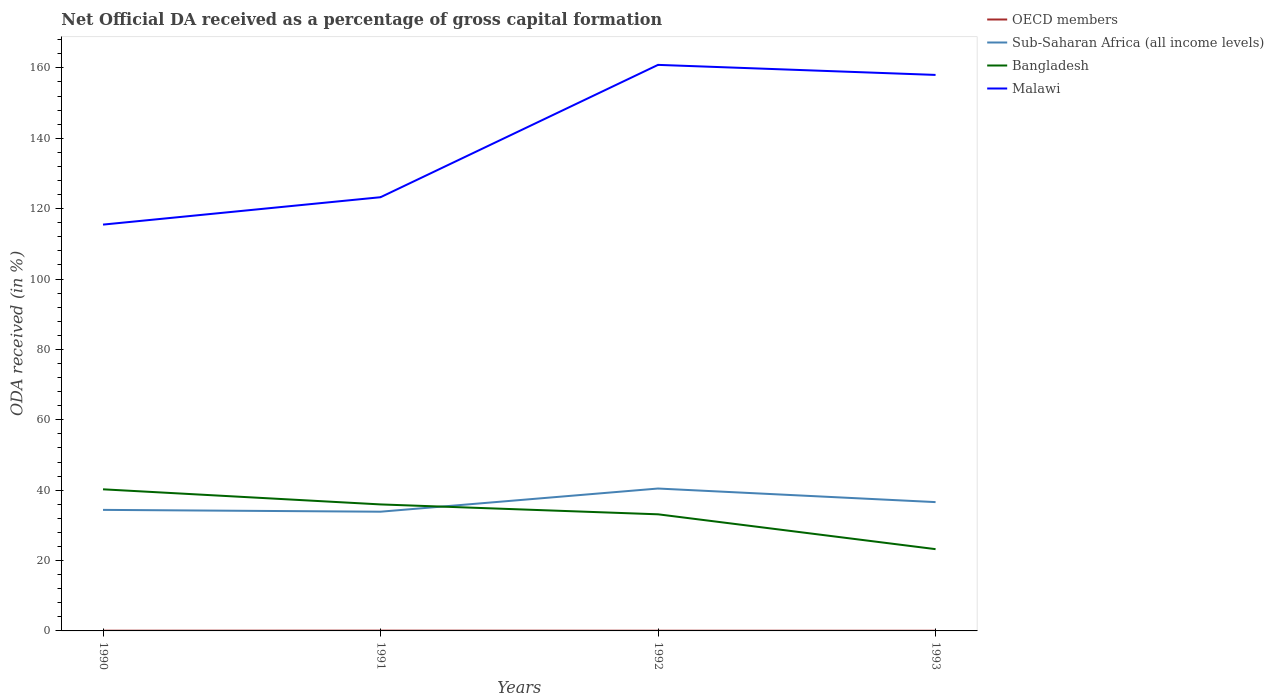Does the line corresponding to Malawi intersect with the line corresponding to Bangladesh?
Offer a terse response. No. Is the number of lines equal to the number of legend labels?
Keep it short and to the point. Yes. Across all years, what is the maximum net ODA received in Sub-Saharan Africa (all income levels)?
Make the answer very short. 33.88. In which year was the net ODA received in Bangladesh maximum?
Your response must be concise. 1993. What is the total net ODA received in OECD members in the graph?
Provide a succinct answer. 0.03. What is the difference between the highest and the second highest net ODA received in Malawi?
Keep it short and to the point. 45.39. What is the difference between the highest and the lowest net ODA received in Malawi?
Your answer should be compact. 2. Is the net ODA received in Malawi strictly greater than the net ODA received in Bangladesh over the years?
Your answer should be compact. No. How many lines are there?
Ensure brevity in your answer.  4. How many years are there in the graph?
Your answer should be very brief. 4. What is the difference between two consecutive major ticks on the Y-axis?
Provide a short and direct response. 20. Are the values on the major ticks of Y-axis written in scientific E-notation?
Keep it short and to the point. No. How many legend labels are there?
Provide a short and direct response. 4. What is the title of the graph?
Provide a succinct answer. Net Official DA received as a percentage of gross capital formation. What is the label or title of the Y-axis?
Offer a very short reply. ODA received (in %). What is the ODA received (in %) in OECD members in 1990?
Your answer should be compact. 0.06. What is the ODA received (in %) in Sub-Saharan Africa (all income levels) in 1990?
Give a very brief answer. 34.4. What is the ODA received (in %) in Bangladesh in 1990?
Your response must be concise. 40.24. What is the ODA received (in %) of Malawi in 1990?
Give a very brief answer. 115.47. What is the ODA received (in %) in OECD members in 1991?
Offer a terse response. 0.08. What is the ODA received (in %) in Sub-Saharan Africa (all income levels) in 1991?
Ensure brevity in your answer.  33.88. What is the ODA received (in %) in Bangladesh in 1991?
Offer a terse response. 35.95. What is the ODA received (in %) of Malawi in 1991?
Keep it short and to the point. 123.25. What is the ODA received (in %) in OECD members in 1992?
Your answer should be compact. 0.06. What is the ODA received (in %) of Sub-Saharan Africa (all income levels) in 1992?
Your answer should be compact. 40.46. What is the ODA received (in %) of Bangladesh in 1992?
Provide a succinct answer. 33.14. What is the ODA received (in %) of Malawi in 1992?
Your answer should be compact. 160.86. What is the ODA received (in %) in OECD members in 1993?
Your answer should be very brief. 0.05. What is the ODA received (in %) of Sub-Saharan Africa (all income levels) in 1993?
Provide a succinct answer. 36.6. What is the ODA received (in %) in Bangladesh in 1993?
Offer a terse response. 23.24. What is the ODA received (in %) in Malawi in 1993?
Offer a terse response. 158. Across all years, what is the maximum ODA received (in %) in OECD members?
Keep it short and to the point. 0.08. Across all years, what is the maximum ODA received (in %) of Sub-Saharan Africa (all income levels)?
Give a very brief answer. 40.46. Across all years, what is the maximum ODA received (in %) in Bangladesh?
Keep it short and to the point. 40.24. Across all years, what is the maximum ODA received (in %) in Malawi?
Provide a short and direct response. 160.86. Across all years, what is the minimum ODA received (in %) in OECD members?
Your answer should be compact. 0.05. Across all years, what is the minimum ODA received (in %) in Sub-Saharan Africa (all income levels)?
Provide a succinct answer. 33.88. Across all years, what is the minimum ODA received (in %) of Bangladesh?
Offer a terse response. 23.24. Across all years, what is the minimum ODA received (in %) in Malawi?
Offer a terse response. 115.47. What is the total ODA received (in %) of OECD members in the graph?
Provide a short and direct response. 0.25. What is the total ODA received (in %) in Sub-Saharan Africa (all income levels) in the graph?
Your answer should be very brief. 145.35. What is the total ODA received (in %) of Bangladesh in the graph?
Keep it short and to the point. 132.56. What is the total ODA received (in %) of Malawi in the graph?
Your answer should be compact. 557.57. What is the difference between the ODA received (in %) in OECD members in 1990 and that in 1991?
Provide a short and direct response. -0.02. What is the difference between the ODA received (in %) in Sub-Saharan Africa (all income levels) in 1990 and that in 1991?
Your answer should be compact. 0.52. What is the difference between the ODA received (in %) of Bangladesh in 1990 and that in 1991?
Offer a very short reply. 4.29. What is the difference between the ODA received (in %) in Malawi in 1990 and that in 1991?
Make the answer very short. -7.78. What is the difference between the ODA received (in %) in OECD members in 1990 and that in 1992?
Provide a short and direct response. 0.01. What is the difference between the ODA received (in %) of Sub-Saharan Africa (all income levels) in 1990 and that in 1992?
Your response must be concise. -6.07. What is the difference between the ODA received (in %) of Bangladesh in 1990 and that in 1992?
Offer a very short reply. 7.1. What is the difference between the ODA received (in %) in Malawi in 1990 and that in 1992?
Give a very brief answer. -45.39. What is the difference between the ODA received (in %) of OECD members in 1990 and that in 1993?
Give a very brief answer. 0.02. What is the difference between the ODA received (in %) of Sub-Saharan Africa (all income levels) in 1990 and that in 1993?
Keep it short and to the point. -2.2. What is the difference between the ODA received (in %) of Bangladesh in 1990 and that in 1993?
Offer a terse response. 17. What is the difference between the ODA received (in %) of Malawi in 1990 and that in 1993?
Provide a short and direct response. -42.53. What is the difference between the ODA received (in %) of OECD members in 1991 and that in 1992?
Make the answer very short. 0.02. What is the difference between the ODA received (in %) of Sub-Saharan Africa (all income levels) in 1991 and that in 1992?
Your response must be concise. -6.58. What is the difference between the ODA received (in %) of Bangladesh in 1991 and that in 1992?
Offer a very short reply. 2.81. What is the difference between the ODA received (in %) in Malawi in 1991 and that in 1992?
Your response must be concise. -37.61. What is the difference between the ODA received (in %) of OECD members in 1991 and that in 1993?
Ensure brevity in your answer.  0.03. What is the difference between the ODA received (in %) of Sub-Saharan Africa (all income levels) in 1991 and that in 1993?
Offer a terse response. -2.72. What is the difference between the ODA received (in %) of Bangladesh in 1991 and that in 1993?
Make the answer very short. 12.71. What is the difference between the ODA received (in %) in Malawi in 1991 and that in 1993?
Your answer should be compact. -34.75. What is the difference between the ODA received (in %) of OECD members in 1992 and that in 1993?
Make the answer very short. 0.01. What is the difference between the ODA received (in %) in Sub-Saharan Africa (all income levels) in 1992 and that in 1993?
Provide a succinct answer. 3.86. What is the difference between the ODA received (in %) of Bangladesh in 1992 and that in 1993?
Provide a succinct answer. 9.9. What is the difference between the ODA received (in %) of Malawi in 1992 and that in 1993?
Your answer should be compact. 2.86. What is the difference between the ODA received (in %) of OECD members in 1990 and the ODA received (in %) of Sub-Saharan Africa (all income levels) in 1991?
Offer a terse response. -33.82. What is the difference between the ODA received (in %) of OECD members in 1990 and the ODA received (in %) of Bangladesh in 1991?
Give a very brief answer. -35.88. What is the difference between the ODA received (in %) in OECD members in 1990 and the ODA received (in %) in Malawi in 1991?
Provide a succinct answer. -123.19. What is the difference between the ODA received (in %) of Sub-Saharan Africa (all income levels) in 1990 and the ODA received (in %) of Bangladesh in 1991?
Provide a short and direct response. -1.55. What is the difference between the ODA received (in %) in Sub-Saharan Africa (all income levels) in 1990 and the ODA received (in %) in Malawi in 1991?
Keep it short and to the point. -88.85. What is the difference between the ODA received (in %) in Bangladesh in 1990 and the ODA received (in %) in Malawi in 1991?
Your response must be concise. -83.01. What is the difference between the ODA received (in %) of OECD members in 1990 and the ODA received (in %) of Sub-Saharan Africa (all income levels) in 1992?
Your answer should be very brief. -40.4. What is the difference between the ODA received (in %) in OECD members in 1990 and the ODA received (in %) in Bangladesh in 1992?
Offer a very short reply. -33.07. What is the difference between the ODA received (in %) in OECD members in 1990 and the ODA received (in %) in Malawi in 1992?
Provide a succinct answer. -160.79. What is the difference between the ODA received (in %) of Sub-Saharan Africa (all income levels) in 1990 and the ODA received (in %) of Bangladesh in 1992?
Provide a short and direct response. 1.26. What is the difference between the ODA received (in %) in Sub-Saharan Africa (all income levels) in 1990 and the ODA received (in %) in Malawi in 1992?
Provide a short and direct response. -126.46. What is the difference between the ODA received (in %) in Bangladesh in 1990 and the ODA received (in %) in Malawi in 1992?
Keep it short and to the point. -120.62. What is the difference between the ODA received (in %) in OECD members in 1990 and the ODA received (in %) in Sub-Saharan Africa (all income levels) in 1993?
Make the answer very short. -36.54. What is the difference between the ODA received (in %) in OECD members in 1990 and the ODA received (in %) in Bangladesh in 1993?
Provide a succinct answer. -23.17. What is the difference between the ODA received (in %) in OECD members in 1990 and the ODA received (in %) in Malawi in 1993?
Provide a short and direct response. -157.93. What is the difference between the ODA received (in %) in Sub-Saharan Africa (all income levels) in 1990 and the ODA received (in %) in Bangladesh in 1993?
Offer a terse response. 11.16. What is the difference between the ODA received (in %) of Sub-Saharan Africa (all income levels) in 1990 and the ODA received (in %) of Malawi in 1993?
Your response must be concise. -123.6. What is the difference between the ODA received (in %) of Bangladesh in 1990 and the ODA received (in %) of Malawi in 1993?
Keep it short and to the point. -117.76. What is the difference between the ODA received (in %) of OECD members in 1991 and the ODA received (in %) of Sub-Saharan Africa (all income levels) in 1992?
Keep it short and to the point. -40.38. What is the difference between the ODA received (in %) in OECD members in 1991 and the ODA received (in %) in Bangladesh in 1992?
Provide a short and direct response. -33.06. What is the difference between the ODA received (in %) in OECD members in 1991 and the ODA received (in %) in Malawi in 1992?
Keep it short and to the point. -160.78. What is the difference between the ODA received (in %) in Sub-Saharan Africa (all income levels) in 1991 and the ODA received (in %) in Bangladesh in 1992?
Give a very brief answer. 0.74. What is the difference between the ODA received (in %) in Sub-Saharan Africa (all income levels) in 1991 and the ODA received (in %) in Malawi in 1992?
Ensure brevity in your answer.  -126.98. What is the difference between the ODA received (in %) of Bangladesh in 1991 and the ODA received (in %) of Malawi in 1992?
Your answer should be compact. -124.91. What is the difference between the ODA received (in %) in OECD members in 1991 and the ODA received (in %) in Sub-Saharan Africa (all income levels) in 1993?
Offer a very short reply. -36.52. What is the difference between the ODA received (in %) of OECD members in 1991 and the ODA received (in %) of Bangladesh in 1993?
Ensure brevity in your answer.  -23.16. What is the difference between the ODA received (in %) in OECD members in 1991 and the ODA received (in %) in Malawi in 1993?
Your answer should be very brief. -157.92. What is the difference between the ODA received (in %) in Sub-Saharan Africa (all income levels) in 1991 and the ODA received (in %) in Bangladesh in 1993?
Provide a short and direct response. 10.64. What is the difference between the ODA received (in %) in Sub-Saharan Africa (all income levels) in 1991 and the ODA received (in %) in Malawi in 1993?
Your answer should be very brief. -124.12. What is the difference between the ODA received (in %) in Bangladesh in 1991 and the ODA received (in %) in Malawi in 1993?
Provide a succinct answer. -122.05. What is the difference between the ODA received (in %) of OECD members in 1992 and the ODA received (in %) of Sub-Saharan Africa (all income levels) in 1993?
Offer a terse response. -36.55. What is the difference between the ODA received (in %) of OECD members in 1992 and the ODA received (in %) of Bangladesh in 1993?
Make the answer very short. -23.18. What is the difference between the ODA received (in %) in OECD members in 1992 and the ODA received (in %) in Malawi in 1993?
Keep it short and to the point. -157.94. What is the difference between the ODA received (in %) of Sub-Saharan Africa (all income levels) in 1992 and the ODA received (in %) of Bangladesh in 1993?
Ensure brevity in your answer.  17.23. What is the difference between the ODA received (in %) in Sub-Saharan Africa (all income levels) in 1992 and the ODA received (in %) in Malawi in 1993?
Your answer should be compact. -117.53. What is the difference between the ODA received (in %) in Bangladesh in 1992 and the ODA received (in %) in Malawi in 1993?
Your response must be concise. -124.86. What is the average ODA received (in %) in OECD members per year?
Provide a succinct answer. 0.06. What is the average ODA received (in %) of Sub-Saharan Africa (all income levels) per year?
Ensure brevity in your answer.  36.34. What is the average ODA received (in %) in Bangladesh per year?
Make the answer very short. 33.14. What is the average ODA received (in %) in Malawi per year?
Offer a very short reply. 139.39. In the year 1990, what is the difference between the ODA received (in %) of OECD members and ODA received (in %) of Sub-Saharan Africa (all income levels)?
Keep it short and to the point. -34.34. In the year 1990, what is the difference between the ODA received (in %) in OECD members and ODA received (in %) in Bangladesh?
Ensure brevity in your answer.  -40.18. In the year 1990, what is the difference between the ODA received (in %) of OECD members and ODA received (in %) of Malawi?
Give a very brief answer. -115.4. In the year 1990, what is the difference between the ODA received (in %) in Sub-Saharan Africa (all income levels) and ODA received (in %) in Bangladesh?
Keep it short and to the point. -5.84. In the year 1990, what is the difference between the ODA received (in %) of Sub-Saharan Africa (all income levels) and ODA received (in %) of Malawi?
Provide a short and direct response. -81.07. In the year 1990, what is the difference between the ODA received (in %) of Bangladesh and ODA received (in %) of Malawi?
Offer a terse response. -75.23. In the year 1991, what is the difference between the ODA received (in %) of OECD members and ODA received (in %) of Sub-Saharan Africa (all income levels)?
Ensure brevity in your answer.  -33.8. In the year 1991, what is the difference between the ODA received (in %) of OECD members and ODA received (in %) of Bangladesh?
Provide a short and direct response. -35.87. In the year 1991, what is the difference between the ODA received (in %) in OECD members and ODA received (in %) in Malawi?
Offer a very short reply. -123.17. In the year 1991, what is the difference between the ODA received (in %) in Sub-Saharan Africa (all income levels) and ODA received (in %) in Bangladesh?
Keep it short and to the point. -2.07. In the year 1991, what is the difference between the ODA received (in %) in Sub-Saharan Africa (all income levels) and ODA received (in %) in Malawi?
Keep it short and to the point. -89.37. In the year 1991, what is the difference between the ODA received (in %) of Bangladesh and ODA received (in %) of Malawi?
Give a very brief answer. -87.3. In the year 1992, what is the difference between the ODA received (in %) in OECD members and ODA received (in %) in Sub-Saharan Africa (all income levels)?
Give a very brief answer. -40.41. In the year 1992, what is the difference between the ODA received (in %) of OECD members and ODA received (in %) of Bangladesh?
Give a very brief answer. -33.08. In the year 1992, what is the difference between the ODA received (in %) in OECD members and ODA received (in %) in Malawi?
Provide a succinct answer. -160.8. In the year 1992, what is the difference between the ODA received (in %) in Sub-Saharan Africa (all income levels) and ODA received (in %) in Bangladesh?
Your response must be concise. 7.33. In the year 1992, what is the difference between the ODA received (in %) of Sub-Saharan Africa (all income levels) and ODA received (in %) of Malawi?
Keep it short and to the point. -120.39. In the year 1992, what is the difference between the ODA received (in %) in Bangladesh and ODA received (in %) in Malawi?
Give a very brief answer. -127.72. In the year 1993, what is the difference between the ODA received (in %) in OECD members and ODA received (in %) in Sub-Saharan Africa (all income levels)?
Your response must be concise. -36.56. In the year 1993, what is the difference between the ODA received (in %) in OECD members and ODA received (in %) in Bangladesh?
Ensure brevity in your answer.  -23.19. In the year 1993, what is the difference between the ODA received (in %) in OECD members and ODA received (in %) in Malawi?
Your answer should be compact. -157.95. In the year 1993, what is the difference between the ODA received (in %) in Sub-Saharan Africa (all income levels) and ODA received (in %) in Bangladesh?
Keep it short and to the point. 13.36. In the year 1993, what is the difference between the ODA received (in %) of Sub-Saharan Africa (all income levels) and ODA received (in %) of Malawi?
Ensure brevity in your answer.  -121.39. In the year 1993, what is the difference between the ODA received (in %) in Bangladesh and ODA received (in %) in Malawi?
Your answer should be compact. -134.76. What is the ratio of the ODA received (in %) of OECD members in 1990 to that in 1991?
Your answer should be very brief. 0.8. What is the ratio of the ODA received (in %) in Sub-Saharan Africa (all income levels) in 1990 to that in 1991?
Offer a very short reply. 1.02. What is the ratio of the ODA received (in %) of Bangladesh in 1990 to that in 1991?
Make the answer very short. 1.12. What is the ratio of the ODA received (in %) of Malawi in 1990 to that in 1991?
Provide a short and direct response. 0.94. What is the ratio of the ODA received (in %) in OECD members in 1990 to that in 1992?
Your answer should be compact. 1.1. What is the ratio of the ODA received (in %) of Sub-Saharan Africa (all income levels) in 1990 to that in 1992?
Offer a terse response. 0.85. What is the ratio of the ODA received (in %) in Bangladesh in 1990 to that in 1992?
Provide a short and direct response. 1.21. What is the ratio of the ODA received (in %) of Malawi in 1990 to that in 1992?
Give a very brief answer. 0.72. What is the ratio of the ODA received (in %) in OECD members in 1990 to that in 1993?
Make the answer very short. 1.37. What is the ratio of the ODA received (in %) in Sub-Saharan Africa (all income levels) in 1990 to that in 1993?
Give a very brief answer. 0.94. What is the ratio of the ODA received (in %) in Bangladesh in 1990 to that in 1993?
Your answer should be very brief. 1.73. What is the ratio of the ODA received (in %) in Malawi in 1990 to that in 1993?
Offer a terse response. 0.73. What is the ratio of the ODA received (in %) of OECD members in 1991 to that in 1992?
Give a very brief answer. 1.38. What is the ratio of the ODA received (in %) of Sub-Saharan Africa (all income levels) in 1991 to that in 1992?
Your response must be concise. 0.84. What is the ratio of the ODA received (in %) of Bangladesh in 1991 to that in 1992?
Ensure brevity in your answer.  1.08. What is the ratio of the ODA received (in %) in Malawi in 1991 to that in 1992?
Keep it short and to the point. 0.77. What is the ratio of the ODA received (in %) of OECD members in 1991 to that in 1993?
Provide a short and direct response. 1.71. What is the ratio of the ODA received (in %) of Sub-Saharan Africa (all income levels) in 1991 to that in 1993?
Offer a very short reply. 0.93. What is the ratio of the ODA received (in %) of Bangladesh in 1991 to that in 1993?
Your response must be concise. 1.55. What is the ratio of the ODA received (in %) in Malawi in 1991 to that in 1993?
Offer a very short reply. 0.78. What is the ratio of the ODA received (in %) in OECD members in 1992 to that in 1993?
Your answer should be compact. 1.24. What is the ratio of the ODA received (in %) of Sub-Saharan Africa (all income levels) in 1992 to that in 1993?
Your response must be concise. 1.11. What is the ratio of the ODA received (in %) of Bangladesh in 1992 to that in 1993?
Ensure brevity in your answer.  1.43. What is the ratio of the ODA received (in %) in Malawi in 1992 to that in 1993?
Provide a succinct answer. 1.02. What is the difference between the highest and the second highest ODA received (in %) in OECD members?
Provide a succinct answer. 0.02. What is the difference between the highest and the second highest ODA received (in %) in Sub-Saharan Africa (all income levels)?
Ensure brevity in your answer.  3.86. What is the difference between the highest and the second highest ODA received (in %) in Bangladesh?
Keep it short and to the point. 4.29. What is the difference between the highest and the second highest ODA received (in %) of Malawi?
Your response must be concise. 2.86. What is the difference between the highest and the lowest ODA received (in %) of Sub-Saharan Africa (all income levels)?
Ensure brevity in your answer.  6.58. What is the difference between the highest and the lowest ODA received (in %) of Bangladesh?
Offer a very short reply. 17. What is the difference between the highest and the lowest ODA received (in %) in Malawi?
Make the answer very short. 45.39. 